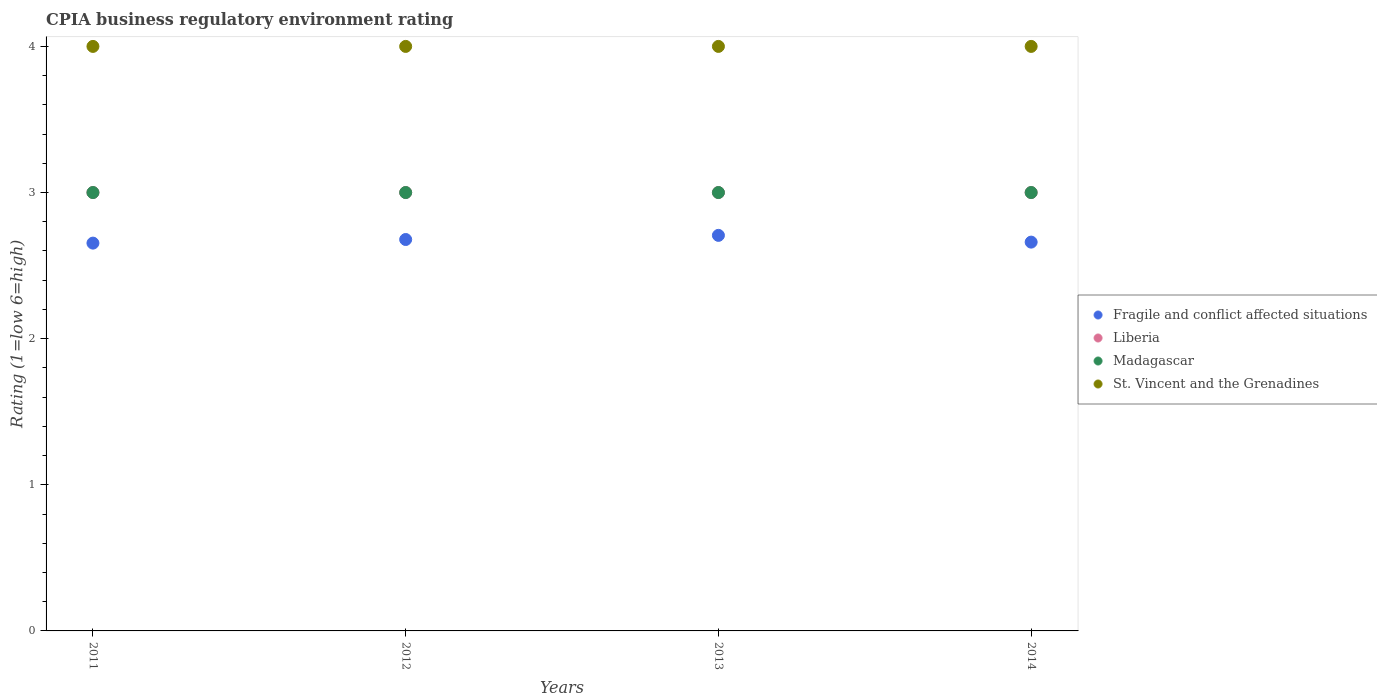How many different coloured dotlines are there?
Give a very brief answer. 4. Is the number of dotlines equal to the number of legend labels?
Your answer should be compact. Yes. Across all years, what is the maximum CPIA rating in Fragile and conflict affected situations?
Ensure brevity in your answer.  2.71. In which year was the CPIA rating in Liberia minimum?
Provide a short and direct response. 2011. What is the difference between the CPIA rating in Fragile and conflict affected situations in 2013 and that in 2014?
Provide a short and direct response. 0.05. What is the difference between the CPIA rating in Liberia in 2011 and the CPIA rating in St. Vincent and the Grenadines in 2014?
Ensure brevity in your answer.  -1. In the year 2012, what is the difference between the CPIA rating in Madagascar and CPIA rating in St. Vincent and the Grenadines?
Keep it short and to the point. -1. In how many years, is the CPIA rating in Madagascar greater than 3?
Keep it short and to the point. 0. What is the ratio of the CPIA rating in Madagascar in 2011 to that in 2013?
Your response must be concise. 1. Is the CPIA rating in Liberia in 2011 less than that in 2012?
Your response must be concise. No. Is the difference between the CPIA rating in Madagascar in 2011 and 2013 greater than the difference between the CPIA rating in St. Vincent and the Grenadines in 2011 and 2013?
Keep it short and to the point. No. What is the difference between the highest and the second highest CPIA rating in Liberia?
Ensure brevity in your answer.  0. Is the sum of the CPIA rating in Liberia in 2012 and 2013 greater than the maximum CPIA rating in Madagascar across all years?
Your response must be concise. Yes. Is it the case that in every year, the sum of the CPIA rating in Liberia and CPIA rating in St. Vincent and the Grenadines  is greater than the sum of CPIA rating in Fragile and conflict affected situations and CPIA rating in Madagascar?
Your answer should be very brief. No. Is the CPIA rating in St. Vincent and the Grenadines strictly less than the CPIA rating in Fragile and conflict affected situations over the years?
Offer a very short reply. No. How many dotlines are there?
Give a very brief answer. 4. How many years are there in the graph?
Your answer should be compact. 4. Does the graph contain any zero values?
Make the answer very short. No. Does the graph contain grids?
Offer a terse response. No. How many legend labels are there?
Ensure brevity in your answer.  4. How are the legend labels stacked?
Provide a succinct answer. Vertical. What is the title of the graph?
Offer a terse response. CPIA business regulatory environment rating. Does "Liechtenstein" appear as one of the legend labels in the graph?
Provide a short and direct response. No. What is the label or title of the X-axis?
Ensure brevity in your answer.  Years. What is the label or title of the Y-axis?
Keep it short and to the point. Rating (1=low 6=high). What is the Rating (1=low 6=high) of Fragile and conflict affected situations in 2011?
Your answer should be compact. 2.65. What is the Rating (1=low 6=high) in Liberia in 2011?
Make the answer very short. 3. What is the Rating (1=low 6=high) of Madagascar in 2011?
Offer a terse response. 3. What is the Rating (1=low 6=high) in St. Vincent and the Grenadines in 2011?
Offer a very short reply. 4. What is the Rating (1=low 6=high) of Fragile and conflict affected situations in 2012?
Your answer should be very brief. 2.68. What is the Rating (1=low 6=high) in Liberia in 2012?
Your response must be concise. 3. What is the Rating (1=low 6=high) in Madagascar in 2012?
Provide a succinct answer. 3. What is the Rating (1=low 6=high) of St. Vincent and the Grenadines in 2012?
Your response must be concise. 4. What is the Rating (1=low 6=high) in Fragile and conflict affected situations in 2013?
Your answer should be very brief. 2.71. What is the Rating (1=low 6=high) of Madagascar in 2013?
Provide a short and direct response. 3. What is the Rating (1=low 6=high) of Fragile and conflict affected situations in 2014?
Offer a terse response. 2.66. Across all years, what is the maximum Rating (1=low 6=high) of Fragile and conflict affected situations?
Provide a succinct answer. 2.71. Across all years, what is the maximum Rating (1=low 6=high) of Madagascar?
Offer a very short reply. 3. Across all years, what is the minimum Rating (1=low 6=high) of Fragile and conflict affected situations?
Provide a short and direct response. 2.65. Across all years, what is the minimum Rating (1=low 6=high) of St. Vincent and the Grenadines?
Make the answer very short. 4. What is the total Rating (1=low 6=high) in Madagascar in the graph?
Give a very brief answer. 12. What is the total Rating (1=low 6=high) in St. Vincent and the Grenadines in the graph?
Your answer should be very brief. 16. What is the difference between the Rating (1=low 6=high) of Fragile and conflict affected situations in 2011 and that in 2012?
Give a very brief answer. -0.02. What is the difference between the Rating (1=low 6=high) of Madagascar in 2011 and that in 2012?
Give a very brief answer. 0. What is the difference between the Rating (1=low 6=high) in St. Vincent and the Grenadines in 2011 and that in 2012?
Keep it short and to the point. 0. What is the difference between the Rating (1=low 6=high) in Fragile and conflict affected situations in 2011 and that in 2013?
Your answer should be very brief. -0.05. What is the difference between the Rating (1=low 6=high) in Liberia in 2011 and that in 2013?
Offer a very short reply. 0. What is the difference between the Rating (1=low 6=high) of Fragile and conflict affected situations in 2011 and that in 2014?
Make the answer very short. -0.01. What is the difference between the Rating (1=low 6=high) in Madagascar in 2011 and that in 2014?
Keep it short and to the point. 0. What is the difference between the Rating (1=low 6=high) in St. Vincent and the Grenadines in 2011 and that in 2014?
Your response must be concise. 0. What is the difference between the Rating (1=low 6=high) in Fragile and conflict affected situations in 2012 and that in 2013?
Your answer should be compact. -0.03. What is the difference between the Rating (1=low 6=high) in Madagascar in 2012 and that in 2013?
Give a very brief answer. 0. What is the difference between the Rating (1=low 6=high) of St. Vincent and the Grenadines in 2012 and that in 2013?
Offer a terse response. 0. What is the difference between the Rating (1=low 6=high) of Fragile and conflict affected situations in 2012 and that in 2014?
Offer a terse response. 0.02. What is the difference between the Rating (1=low 6=high) in Madagascar in 2012 and that in 2014?
Offer a very short reply. 0. What is the difference between the Rating (1=low 6=high) in Fragile and conflict affected situations in 2013 and that in 2014?
Give a very brief answer. 0.05. What is the difference between the Rating (1=low 6=high) of Liberia in 2013 and that in 2014?
Give a very brief answer. 0. What is the difference between the Rating (1=low 6=high) in Madagascar in 2013 and that in 2014?
Your response must be concise. 0. What is the difference between the Rating (1=low 6=high) in St. Vincent and the Grenadines in 2013 and that in 2014?
Ensure brevity in your answer.  0. What is the difference between the Rating (1=low 6=high) of Fragile and conflict affected situations in 2011 and the Rating (1=low 6=high) of Liberia in 2012?
Make the answer very short. -0.35. What is the difference between the Rating (1=low 6=high) in Fragile and conflict affected situations in 2011 and the Rating (1=low 6=high) in Madagascar in 2012?
Ensure brevity in your answer.  -0.35. What is the difference between the Rating (1=low 6=high) of Fragile and conflict affected situations in 2011 and the Rating (1=low 6=high) of St. Vincent and the Grenadines in 2012?
Your answer should be compact. -1.35. What is the difference between the Rating (1=low 6=high) in Liberia in 2011 and the Rating (1=low 6=high) in St. Vincent and the Grenadines in 2012?
Offer a terse response. -1. What is the difference between the Rating (1=low 6=high) in Fragile and conflict affected situations in 2011 and the Rating (1=low 6=high) in Liberia in 2013?
Ensure brevity in your answer.  -0.35. What is the difference between the Rating (1=low 6=high) of Fragile and conflict affected situations in 2011 and the Rating (1=low 6=high) of Madagascar in 2013?
Your answer should be compact. -0.35. What is the difference between the Rating (1=low 6=high) in Fragile and conflict affected situations in 2011 and the Rating (1=low 6=high) in St. Vincent and the Grenadines in 2013?
Provide a succinct answer. -1.35. What is the difference between the Rating (1=low 6=high) of Liberia in 2011 and the Rating (1=low 6=high) of Madagascar in 2013?
Keep it short and to the point. 0. What is the difference between the Rating (1=low 6=high) in Fragile and conflict affected situations in 2011 and the Rating (1=low 6=high) in Liberia in 2014?
Make the answer very short. -0.35. What is the difference between the Rating (1=low 6=high) in Fragile and conflict affected situations in 2011 and the Rating (1=low 6=high) in Madagascar in 2014?
Your answer should be compact. -0.35. What is the difference between the Rating (1=low 6=high) in Fragile and conflict affected situations in 2011 and the Rating (1=low 6=high) in St. Vincent and the Grenadines in 2014?
Give a very brief answer. -1.35. What is the difference between the Rating (1=low 6=high) in Liberia in 2011 and the Rating (1=low 6=high) in Madagascar in 2014?
Provide a short and direct response. 0. What is the difference between the Rating (1=low 6=high) in Madagascar in 2011 and the Rating (1=low 6=high) in St. Vincent and the Grenadines in 2014?
Offer a very short reply. -1. What is the difference between the Rating (1=low 6=high) in Fragile and conflict affected situations in 2012 and the Rating (1=low 6=high) in Liberia in 2013?
Your answer should be compact. -0.32. What is the difference between the Rating (1=low 6=high) of Fragile and conflict affected situations in 2012 and the Rating (1=low 6=high) of Madagascar in 2013?
Offer a terse response. -0.32. What is the difference between the Rating (1=low 6=high) of Fragile and conflict affected situations in 2012 and the Rating (1=low 6=high) of St. Vincent and the Grenadines in 2013?
Provide a short and direct response. -1.32. What is the difference between the Rating (1=low 6=high) in Liberia in 2012 and the Rating (1=low 6=high) in Madagascar in 2013?
Make the answer very short. 0. What is the difference between the Rating (1=low 6=high) in Liberia in 2012 and the Rating (1=low 6=high) in St. Vincent and the Grenadines in 2013?
Give a very brief answer. -1. What is the difference between the Rating (1=low 6=high) of Fragile and conflict affected situations in 2012 and the Rating (1=low 6=high) of Liberia in 2014?
Give a very brief answer. -0.32. What is the difference between the Rating (1=low 6=high) in Fragile and conflict affected situations in 2012 and the Rating (1=low 6=high) in Madagascar in 2014?
Keep it short and to the point. -0.32. What is the difference between the Rating (1=low 6=high) in Fragile and conflict affected situations in 2012 and the Rating (1=low 6=high) in St. Vincent and the Grenadines in 2014?
Ensure brevity in your answer.  -1.32. What is the difference between the Rating (1=low 6=high) of Liberia in 2012 and the Rating (1=low 6=high) of Madagascar in 2014?
Give a very brief answer. 0. What is the difference between the Rating (1=low 6=high) in Liberia in 2012 and the Rating (1=low 6=high) in St. Vincent and the Grenadines in 2014?
Offer a terse response. -1. What is the difference between the Rating (1=low 6=high) in Madagascar in 2012 and the Rating (1=low 6=high) in St. Vincent and the Grenadines in 2014?
Offer a terse response. -1. What is the difference between the Rating (1=low 6=high) in Fragile and conflict affected situations in 2013 and the Rating (1=low 6=high) in Liberia in 2014?
Your answer should be compact. -0.29. What is the difference between the Rating (1=low 6=high) in Fragile and conflict affected situations in 2013 and the Rating (1=low 6=high) in Madagascar in 2014?
Offer a very short reply. -0.29. What is the difference between the Rating (1=low 6=high) in Fragile and conflict affected situations in 2013 and the Rating (1=low 6=high) in St. Vincent and the Grenadines in 2014?
Keep it short and to the point. -1.29. What is the difference between the Rating (1=low 6=high) of Liberia in 2013 and the Rating (1=low 6=high) of St. Vincent and the Grenadines in 2014?
Keep it short and to the point. -1. What is the average Rating (1=low 6=high) of Fragile and conflict affected situations per year?
Provide a short and direct response. 2.67. What is the average Rating (1=low 6=high) of Liberia per year?
Your answer should be very brief. 3. What is the average Rating (1=low 6=high) in St. Vincent and the Grenadines per year?
Your answer should be compact. 4. In the year 2011, what is the difference between the Rating (1=low 6=high) in Fragile and conflict affected situations and Rating (1=low 6=high) in Liberia?
Give a very brief answer. -0.35. In the year 2011, what is the difference between the Rating (1=low 6=high) in Fragile and conflict affected situations and Rating (1=low 6=high) in Madagascar?
Ensure brevity in your answer.  -0.35. In the year 2011, what is the difference between the Rating (1=low 6=high) of Fragile and conflict affected situations and Rating (1=low 6=high) of St. Vincent and the Grenadines?
Keep it short and to the point. -1.35. In the year 2011, what is the difference between the Rating (1=low 6=high) of Madagascar and Rating (1=low 6=high) of St. Vincent and the Grenadines?
Your answer should be compact. -1. In the year 2012, what is the difference between the Rating (1=low 6=high) in Fragile and conflict affected situations and Rating (1=low 6=high) in Liberia?
Your answer should be compact. -0.32. In the year 2012, what is the difference between the Rating (1=low 6=high) of Fragile and conflict affected situations and Rating (1=low 6=high) of Madagascar?
Keep it short and to the point. -0.32. In the year 2012, what is the difference between the Rating (1=low 6=high) of Fragile and conflict affected situations and Rating (1=low 6=high) of St. Vincent and the Grenadines?
Make the answer very short. -1.32. In the year 2012, what is the difference between the Rating (1=low 6=high) in Madagascar and Rating (1=low 6=high) in St. Vincent and the Grenadines?
Provide a succinct answer. -1. In the year 2013, what is the difference between the Rating (1=low 6=high) of Fragile and conflict affected situations and Rating (1=low 6=high) of Liberia?
Ensure brevity in your answer.  -0.29. In the year 2013, what is the difference between the Rating (1=low 6=high) of Fragile and conflict affected situations and Rating (1=low 6=high) of Madagascar?
Offer a very short reply. -0.29. In the year 2013, what is the difference between the Rating (1=low 6=high) of Fragile and conflict affected situations and Rating (1=low 6=high) of St. Vincent and the Grenadines?
Keep it short and to the point. -1.29. In the year 2013, what is the difference between the Rating (1=low 6=high) in Liberia and Rating (1=low 6=high) in Madagascar?
Ensure brevity in your answer.  0. In the year 2014, what is the difference between the Rating (1=low 6=high) in Fragile and conflict affected situations and Rating (1=low 6=high) in Liberia?
Ensure brevity in your answer.  -0.34. In the year 2014, what is the difference between the Rating (1=low 6=high) of Fragile and conflict affected situations and Rating (1=low 6=high) of Madagascar?
Make the answer very short. -0.34. In the year 2014, what is the difference between the Rating (1=low 6=high) of Fragile and conflict affected situations and Rating (1=low 6=high) of St. Vincent and the Grenadines?
Provide a succinct answer. -1.34. In the year 2014, what is the difference between the Rating (1=low 6=high) in Liberia and Rating (1=low 6=high) in Madagascar?
Keep it short and to the point. 0. In the year 2014, what is the difference between the Rating (1=low 6=high) in Madagascar and Rating (1=low 6=high) in St. Vincent and the Grenadines?
Your answer should be very brief. -1. What is the ratio of the Rating (1=low 6=high) of Liberia in 2011 to that in 2012?
Ensure brevity in your answer.  1. What is the ratio of the Rating (1=low 6=high) in Madagascar in 2011 to that in 2012?
Make the answer very short. 1. What is the ratio of the Rating (1=low 6=high) of Fragile and conflict affected situations in 2011 to that in 2013?
Your answer should be very brief. 0.98. What is the ratio of the Rating (1=low 6=high) of Liberia in 2011 to that in 2013?
Make the answer very short. 1. What is the ratio of the Rating (1=low 6=high) of Madagascar in 2011 to that in 2013?
Make the answer very short. 1. What is the ratio of the Rating (1=low 6=high) in St. Vincent and the Grenadines in 2011 to that in 2013?
Make the answer very short. 1. What is the ratio of the Rating (1=low 6=high) in St. Vincent and the Grenadines in 2011 to that in 2014?
Ensure brevity in your answer.  1. What is the ratio of the Rating (1=low 6=high) in Fragile and conflict affected situations in 2012 to that in 2013?
Offer a terse response. 0.99. What is the ratio of the Rating (1=low 6=high) in St. Vincent and the Grenadines in 2012 to that in 2013?
Offer a terse response. 1. What is the ratio of the Rating (1=low 6=high) of Fragile and conflict affected situations in 2012 to that in 2014?
Make the answer very short. 1.01. What is the ratio of the Rating (1=low 6=high) in Liberia in 2012 to that in 2014?
Your answer should be very brief. 1. What is the ratio of the Rating (1=low 6=high) of Fragile and conflict affected situations in 2013 to that in 2014?
Your response must be concise. 1.02. What is the ratio of the Rating (1=low 6=high) of Liberia in 2013 to that in 2014?
Make the answer very short. 1. What is the ratio of the Rating (1=low 6=high) of Madagascar in 2013 to that in 2014?
Keep it short and to the point. 1. What is the ratio of the Rating (1=low 6=high) in St. Vincent and the Grenadines in 2013 to that in 2014?
Give a very brief answer. 1. What is the difference between the highest and the second highest Rating (1=low 6=high) of Fragile and conflict affected situations?
Keep it short and to the point. 0.03. What is the difference between the highest and the lowest Rating (1=low 6=high) of Fragile and conflict affected situations?
Make the answer very short. 0.05. What is the difference between the highest and the lowest Rating (1=low 6=high) of St. Vincent and the Grenadines?
Make the answer very short. 0. 